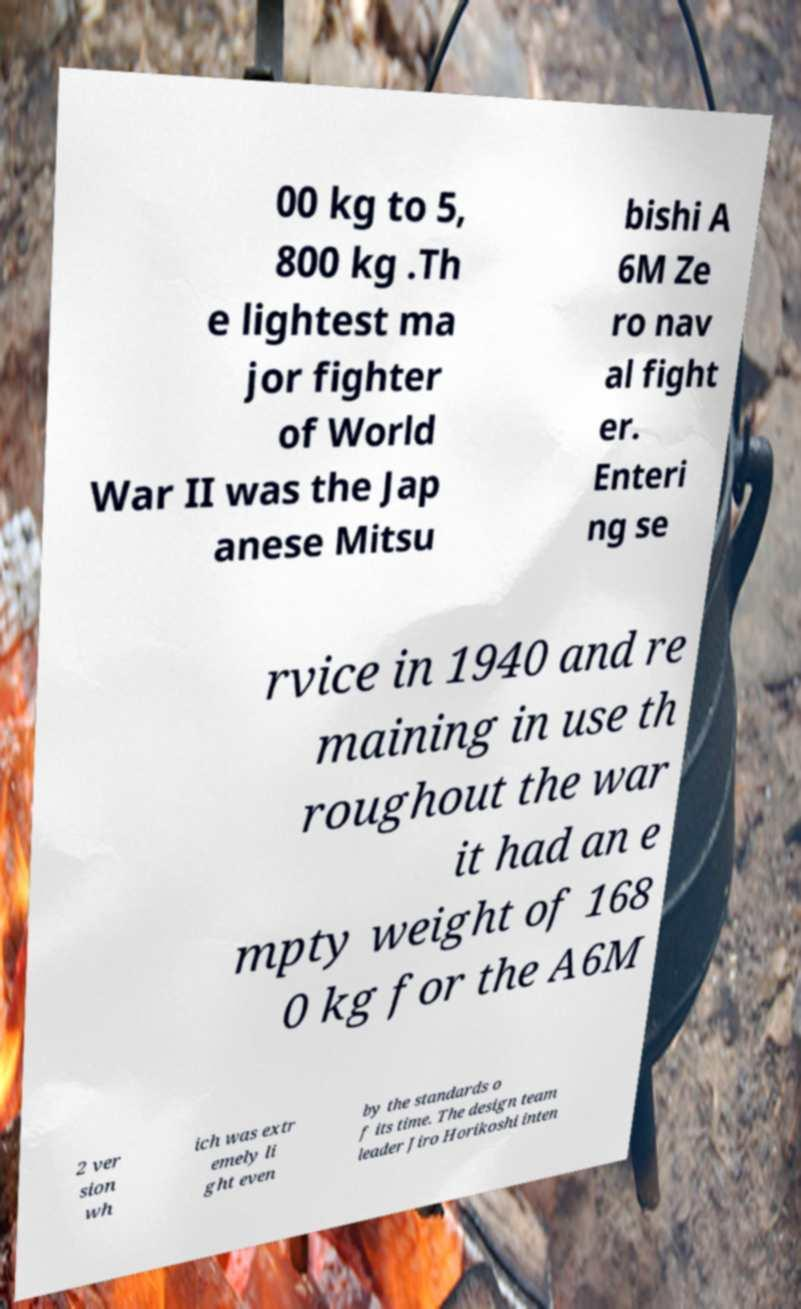What messages or text are displayed in this image? I need them in a readable, typed format. 00 kg to 5, 800 kg .Th e lightest ma jor fighter of World War II was the Jap anese Mitsu bishi A 6M Ze ro nav al fight er. Enteri ng se rvice in 1940 and re maining in use th roughout the war it had an e mpty weight of 168 0 kg for the A6M 2 ver sion wh ich was extr emely li ght even by the standards o f its time. The design team leader Jiro Horikoshi inten 